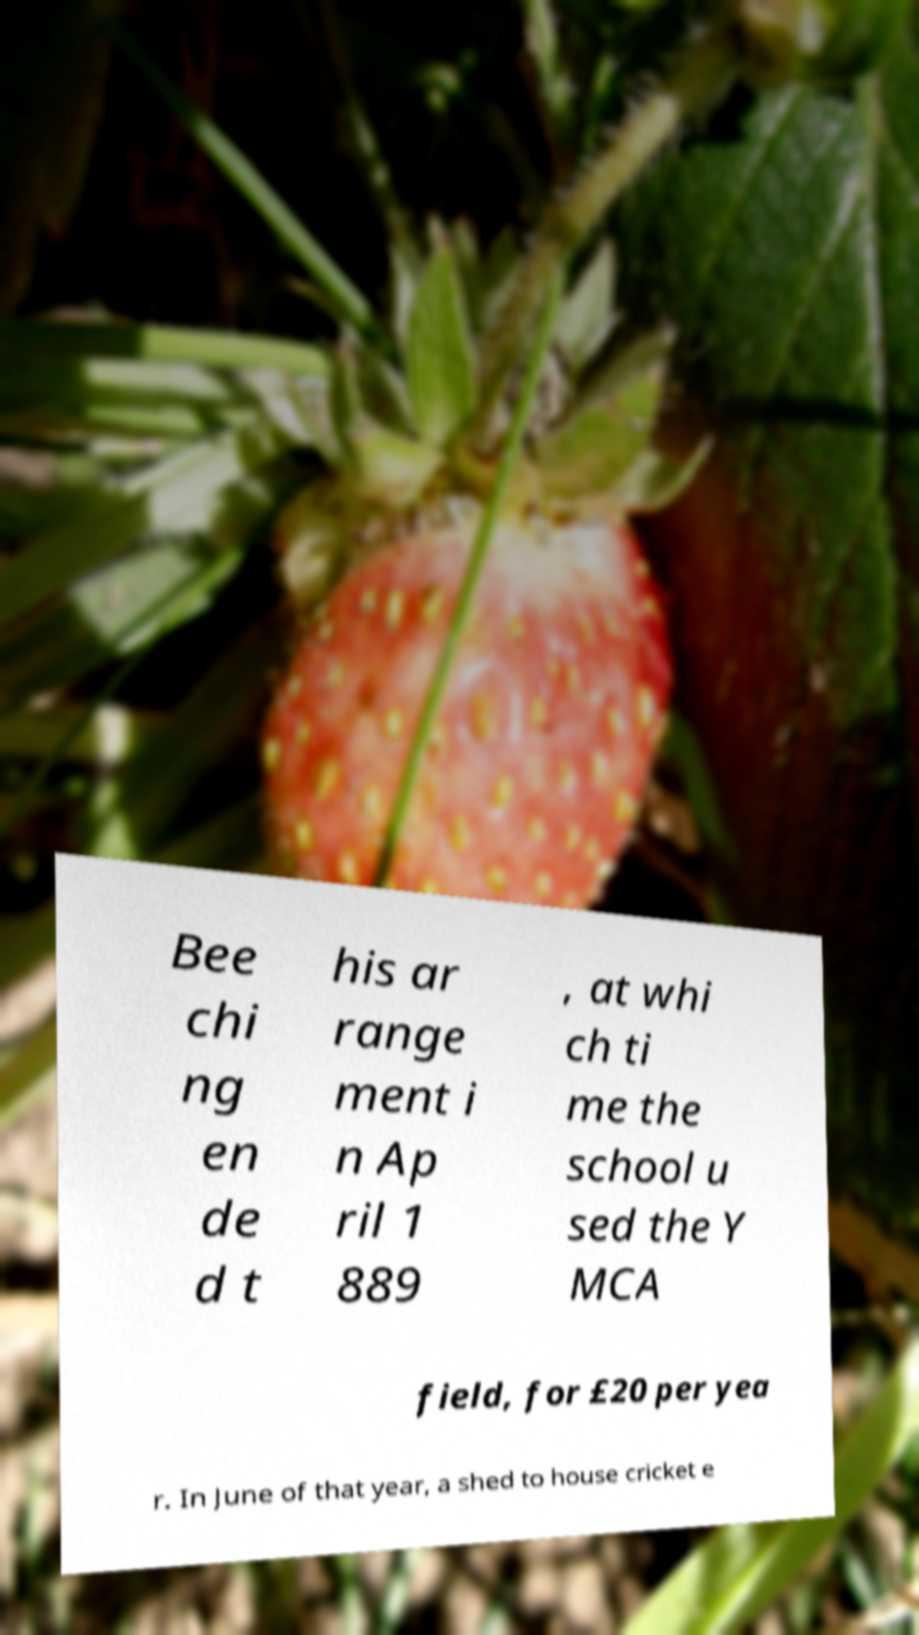Can you read and provide the text displayed in the image?This photo seems to have some interesting text. Can you extract and type it out for me? Bee chi ng en de d t his ar range ment i n Ap ril 1 889 , at whi ch ti me the school u sed the Y MCA field, for £20 per yea r. In June of that year, a shed to house cricket e 